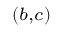Convert formula to latex. <formula><loc_0><loc_0><loc_500><loc_500>^ { ( b , c ) }</formula> 